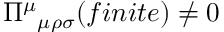<formula> <loc_0><loc_0><loc_500><loc_500>\Pi ^ { \mu _ { \mu \rho \sigma } ( f i n i t e ) \neq 0</formula> 